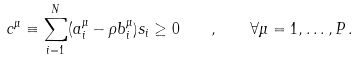Convert formula to latex. <formula><loc_0><loc_0><loc_500><loc_500>c ^ { \mu } \equiv \sum _ { i = 1 } ^ { N } ( a _ { i } ^ { \mu } - \rho b _ { i } ^ { \mu } ) s _ { i } \geq 0 \quad , \quad \forall \mu = 1 , \dots , P \, .</formula> 